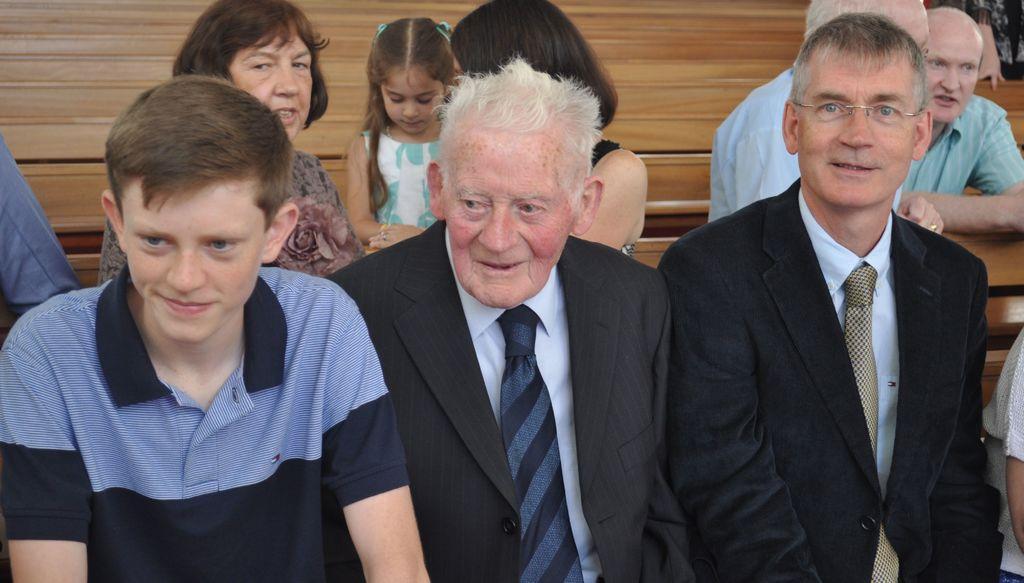Describe this image in one or two sentences. In this image there are group of persons sitting, there are persons truncated towards the right of the image, there is a person truncated towards the left of the image, there is the wood in the background of the image. 